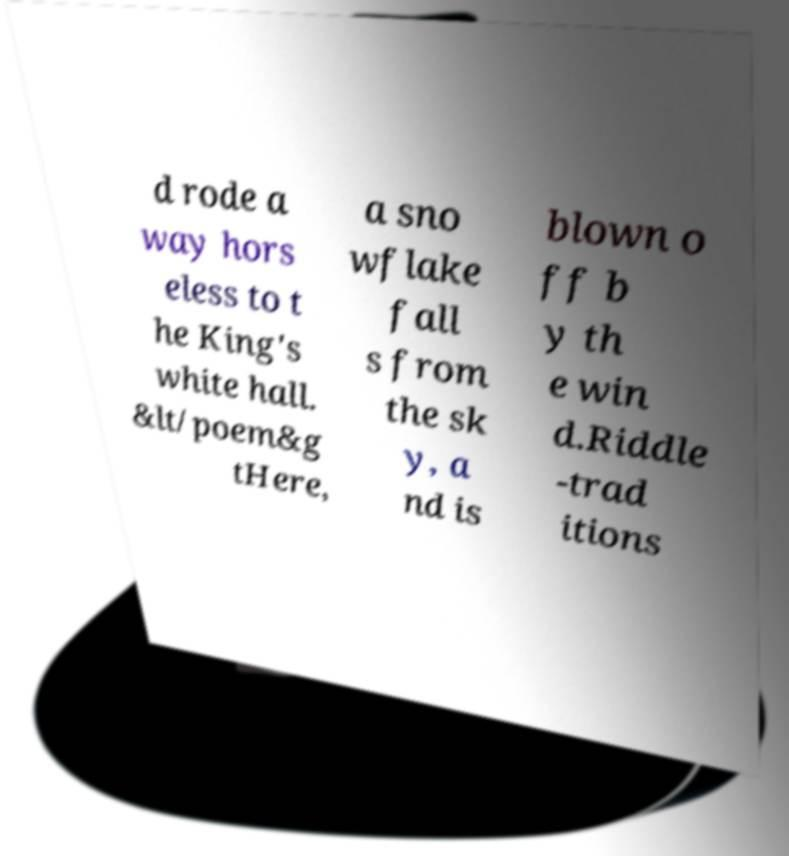What messages or text are displayed in this image? I need them in a readable, typed format. d rode a way hors eless to t he King's white hall. &lt/poem&g tHere, a sno wflake fall s from the sk y, a nd is blown o ff b y th e win d.Riddle -trad itions 